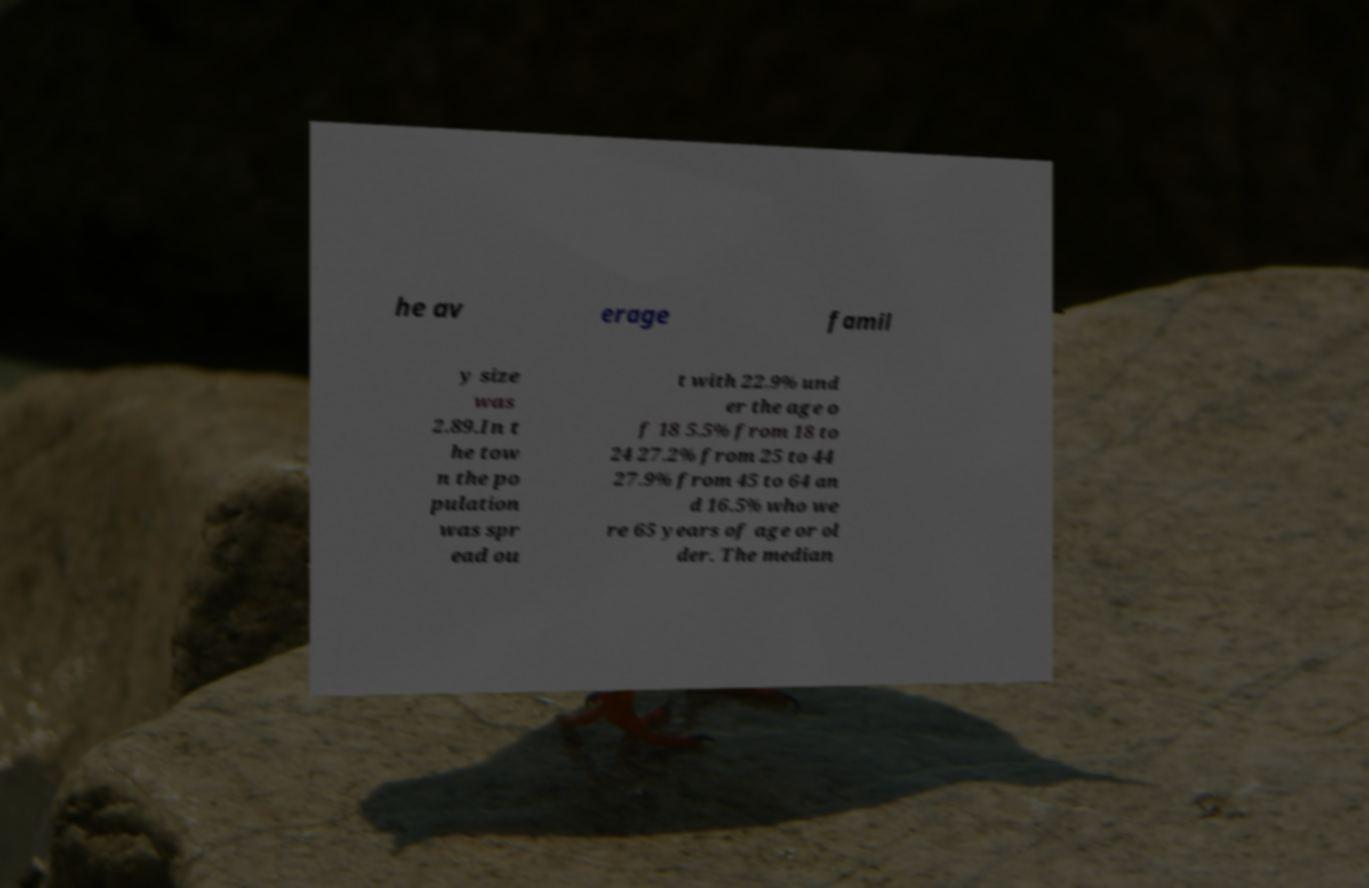Can you accurately transcribe the text from the provided image for me? he av erage famil y size was 2.89.In t he tow n the po pulation was spr ead ou t with 22.9% und er the age o f 18 5.5% from 18 to 24 27.2% from 25 to 44 27.9% from 45 to 64 an d 16.5% who we re 65 years of age or ol der. The median 